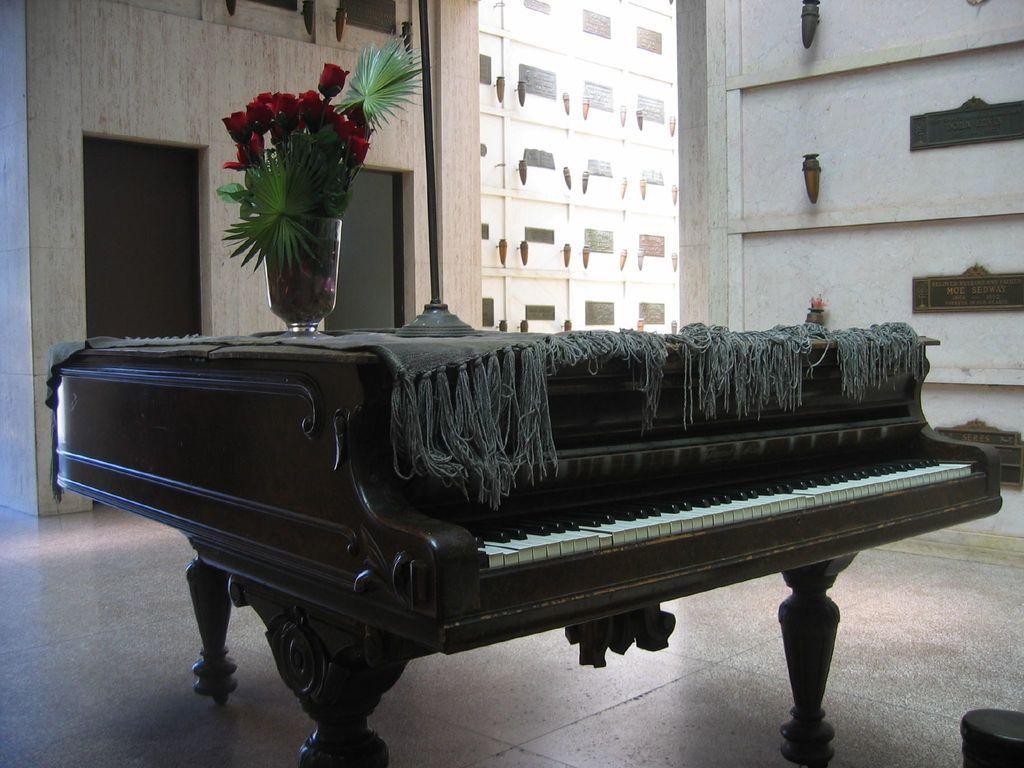Please provide a concise description of this image. In this image i can see a piano on which there is a flower vase. In the background i can see a building, a wall and a door. 